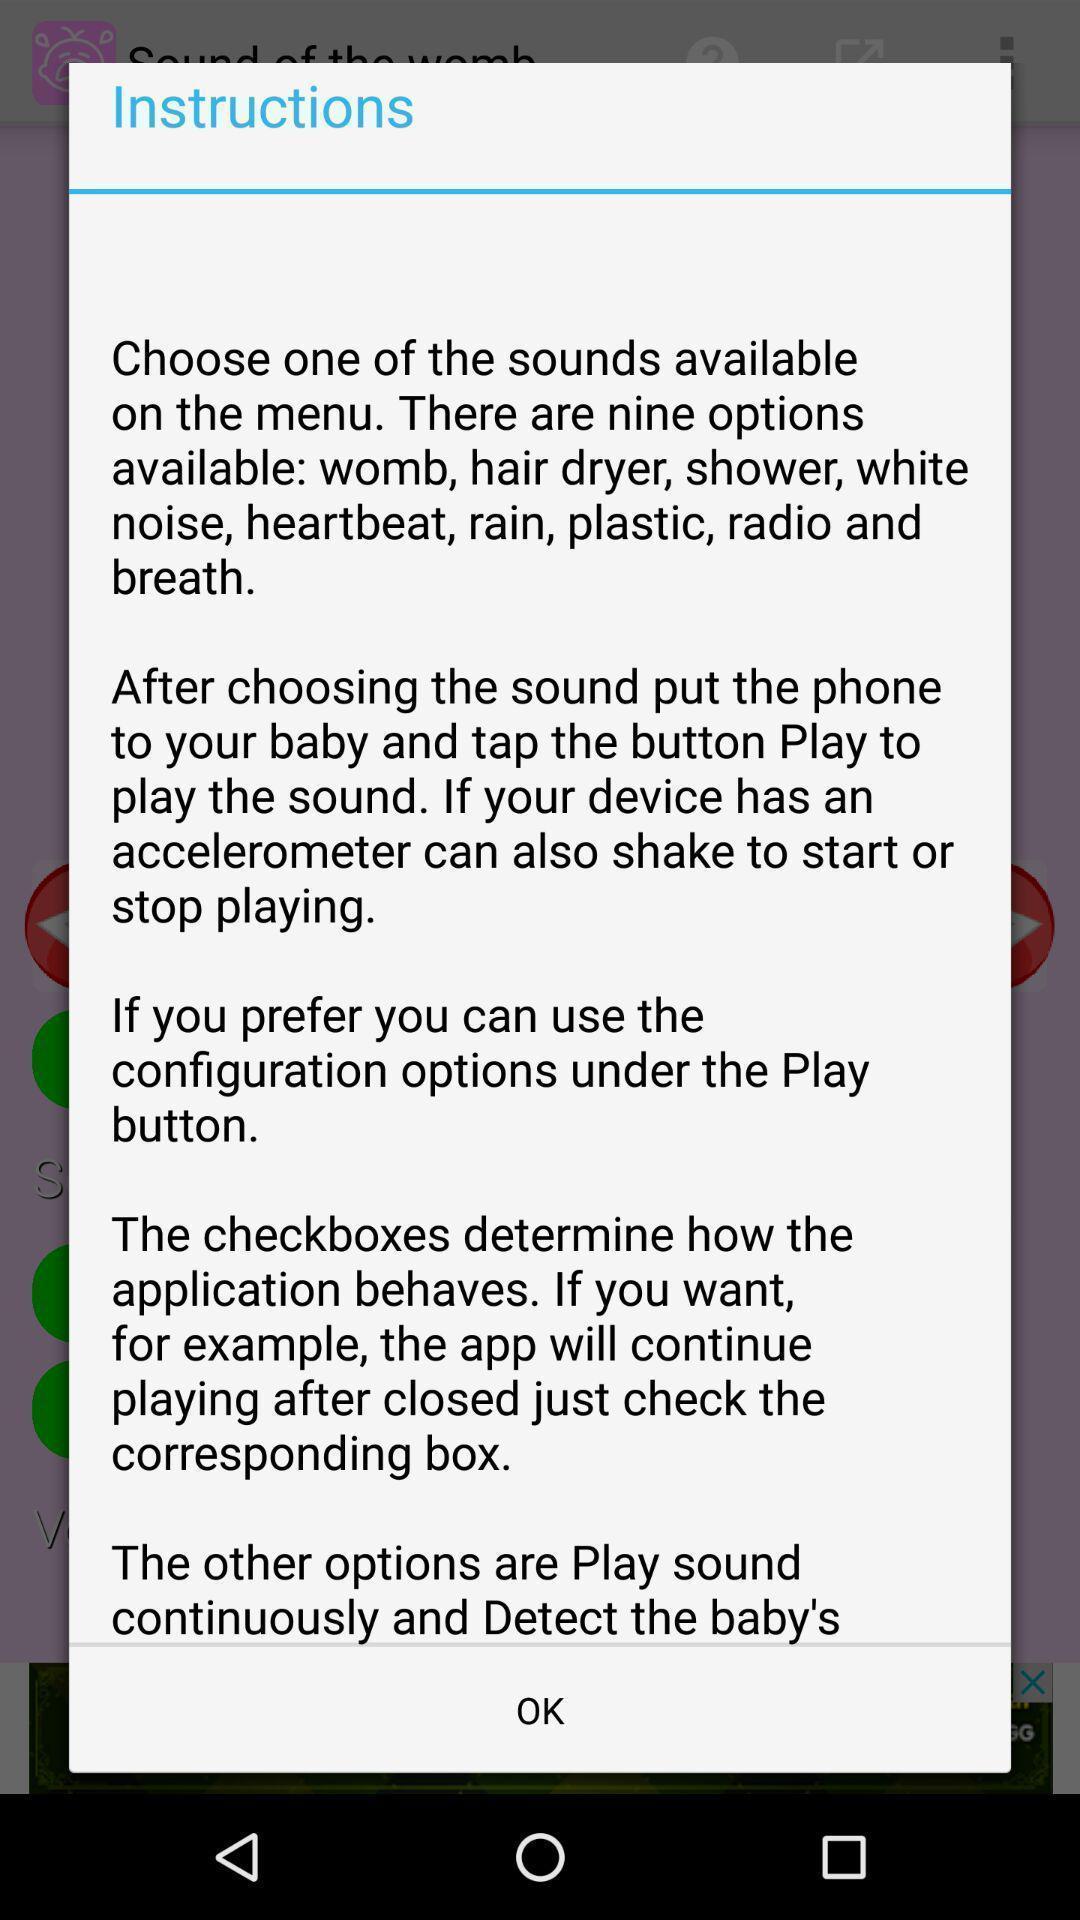What is the overall content of this screenshot? Pop-up screen displaying with the instructions. 